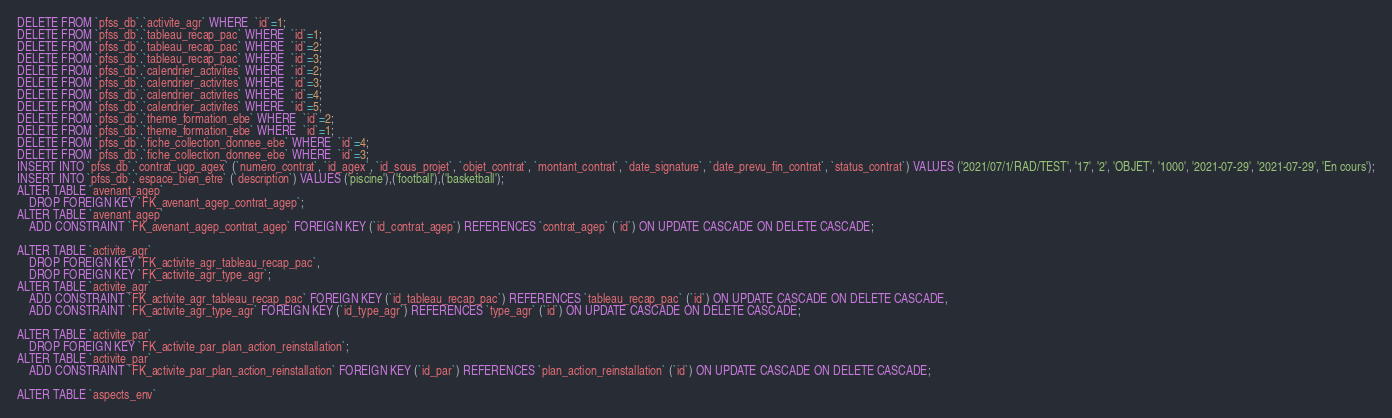<code> <loc_0><loc_0><loc_500><loc_500><_SQL_>DELETE FROM `pfss_db`.`activite_agr` WHERE  `id`=1;
DELETE FROM `pfss_db`.`tableau_recap_pac` WHERE  `id`=1;
DELETE FROM `pfss_db`.`tableau_recap_pac` WHERE  `id`=2;
DELETE FROM `pfss_db`.`tableau_recap_pac` WHERE  `id`=3;
DELETE FROM `pfss_db`.`calendrier_activites` WHERE  `id`=2;
DELETE FROM `pfss_db`.`calendrier_activites` WHERE  `id`=3;
DELETE FROM `pfss_db`.`calendrier_activites` WHERE  `id`=4;
DELETE FROM `pfss_db`.`calendrier_activites` WHERE  `id`=5;
DELETE FROM `pfss_db`.`theme_formation_ebe` WHERE  `id`=2;
DELETE FROM `pfss_db`.`theme_formation_ebe` WHERE  `id`=1;
DELETE FROM `pfss_db`.`fiche_collection_donnee_ebe` WHERE  `id`=4;
DELETE FROM `pfss_db`.`fiche_collection_donnee_ebe` WHERE  `id`=3;
INSERT INTO `pfss_db`.`contrat_ugp_agex` (`numero_contrat`, `id_agex`, `id_sous_projet`, `objet_contrat`, `montant_contrat`, `date_signature`, `date_prevu_fin_contrat`, `status_contrat`) VALUES ('2021/07/1/RAD/TEST', '17', '2', 'OBJET', '1000', '2021-07-29', '2021-07-29', 'En cours');
INSERT INTO `pfss_db`.`espace_bien_etre` (`description`) VALUES ('piscine'),('football'),('basketball');
ALTER TABLE `avenant_agep`
	DROP FOREIGN KEY `FK_avenant_agep_contrat_agep`;
ALTER TABLE `avenant_agep`
	ADD CONSTRAINT `FK_avenant_agep_contrat_agep` FOREIGN KEY (`id_contrat_agep`) REFERENCES `contrat_agep` (`id`) ON UPDATE CASCADE ON DELETE CASCADE;

ALTER TABLE `activite_agr`
	DROP FOREIGN KEY `FK_activite_agr_tableau_recap_pac`,
	DROP FOREIGN KEY `FK_activite_agr_type_agr`;
ALTER TABLE `activite_agr`
	ADD CONSTRAINT `FK_activite_agr_tableau_recap_pac` FOREIGN KEY (`id_tableau_recap_pac`) REFERENCES `tableau_recap_pac` (`id`) ON UPDATE CASCADE ON DELETE CASCADE,
	ADD CONSTRAINT `FK_activite_agr_type_agr` FOREIGN KEY (`id_type_agr`) REFERENCES `type_agr` (`id`) ON UPDATE CASCADE ON DELETE CASCADE;

ALTER TABLE `activite_par`
	DROP FOREIGN KEY `FK_activite_par_plan_action_reinstallation`;
ALTER TABLE `activite_par`
	ADD CONSTRAINT `FK_activite_par_plan_action_reinstallation` FOREIGN KEY (`id_par`) REFERENCES `plan_action_reinstallation` (`id`) ON UPDATE CASCADE ON DELETE CASCADE;

ALTER TABLE `aspects_env`</code> 